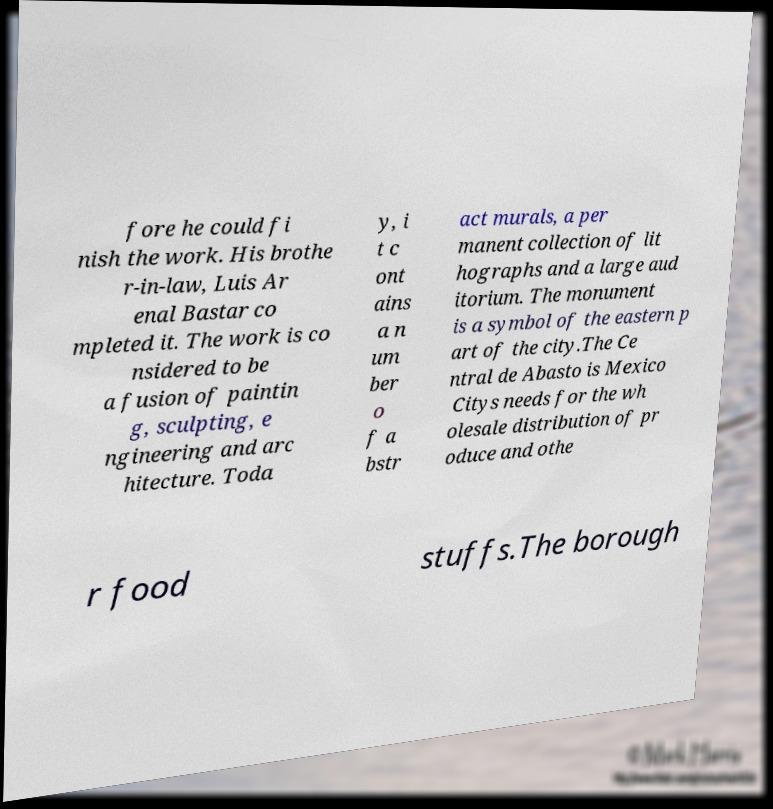Can you read and provide the text displayed in the image?This photo seems to have some interesting text. Can you extract and type it out for me? fore he could fi nish the work. His brothe r-in-law, Luis Ar enal Bastar co mpleted it. The work is co nsidered to be a fusion of paintin g, sculpting, e ngineering and arc hitecture. Toda y, i t c ont ains a n um ber o f a bstr act murals, a per manent collection of lit hographs and a large aud itorium. The monument is a symbol of the eastern p art of the city.The Ce ntral de Abasto is Mexico Citys needs for the wh olesale distribution of pr oduce and othe r food stuffs.The borough 